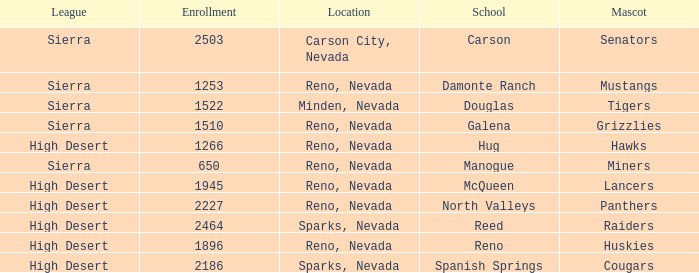Which leagues have Raiders as their mascot? High Desert. Help me parse the entirety of this table. {'header': ['League', 'Enrollment', 'Location', 'School', 'Mascot'], 'rows': [['Sierra', '2503', 'Carson City, Nevada', 'Carson', 'Senators'], ['Sierra', '1253', 'Reno, Nevada', 'Damonte Ranch', 'Mustangs'], ['Sierra', '1522', 'Minden, Nevada', 'Douglas', 'Tigers'], ['Sierra', '1510', 'Reno, Nevada', 'Galena', 'Grizzlies'], ['High Desert', '1266', 'Reno, Nevada', 'Hug', 'Hawks'], ['Sierra', '650', 'Reno, Nevada', 'Manogue', 'Miners'], ['High Desert', '1945', 'Reno, Nevada', 'McQueen', 'Lancers'], ['High Desert', '2227', 'Reno, Nevada', 'North Valleys', 'Panthers'], ['High Desert', '2464', 'Sparks, Nevada', 'Reed', 'Raiders'], ['High Desert', '1896', 'Reno, Nevada', 'Reno', 'Huskies'], ['High Desert', '2186', 'Sparks, Nevada', 'Spanish Springs', 'Cougars']]} 